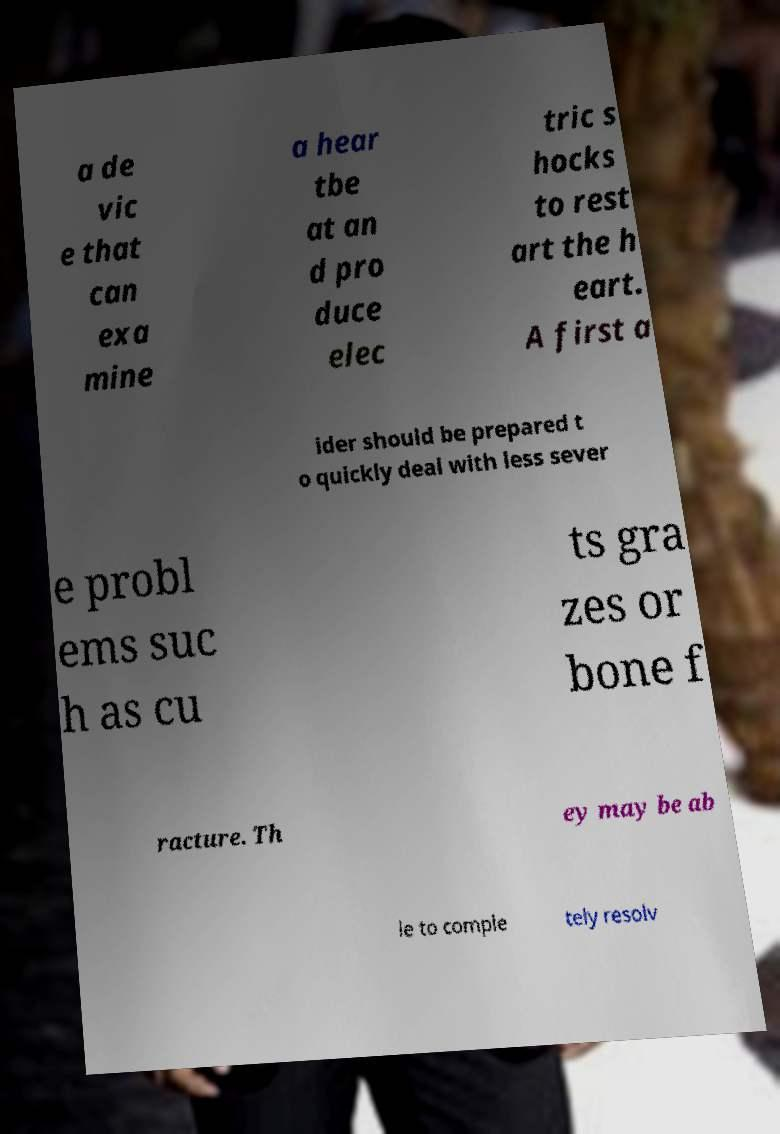There's text embedded in this image that I need extracted. Can you transcribe it verbatim? a de vic e that can exa mine a hear tbe at an d pro duce elec tric s hocks to rest art the h eart. A first a ider should be prepared t o quickly deal with less sever e probl ems suc h as cu ts gra zes or bone f racture. Th ey may be ab le to comple tely resolv 